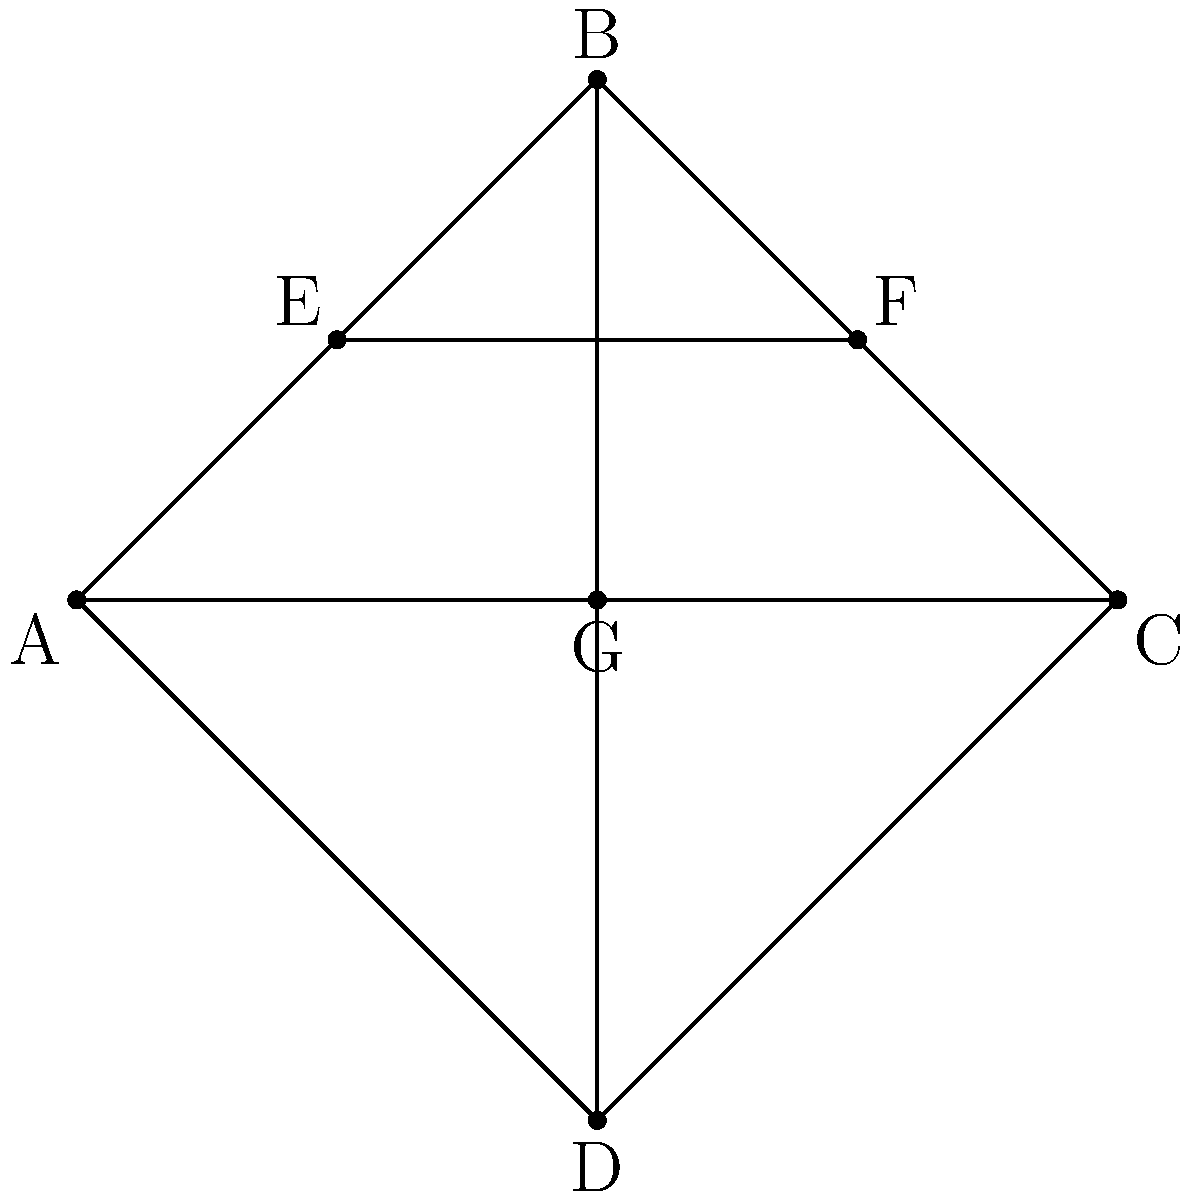In the given network of intersecting lines representing tattoo designs, what is the minimum number of lines that need to be removed to disconnect node A from node C? To solve this problem, we need to analyze the paths connecting nodes A and C:

1. First, identify all paths from A to C:
   - Path 1: A → B → C
   - Path 2: A → D → C
   - Path 3: A → C (direct)

2. To disconnect A from C, we need to break all these paths.

3. Removing the line A-C breaks Path 3, but Paths 1 and 2 still exist.

4. We can break the remaining paths by either:
   a) Removing B-C and D-C
   b) Removing A-B and A-D

5. Option (b) is more efficient as it requires removing only two lines total (A-C and either A-B or A-D).

6. Therefore, the minimum number of lines to remove is 2.

This solution ensures that no path remains between A and C, effectively disconnecting them in the network.
Answer: 2 